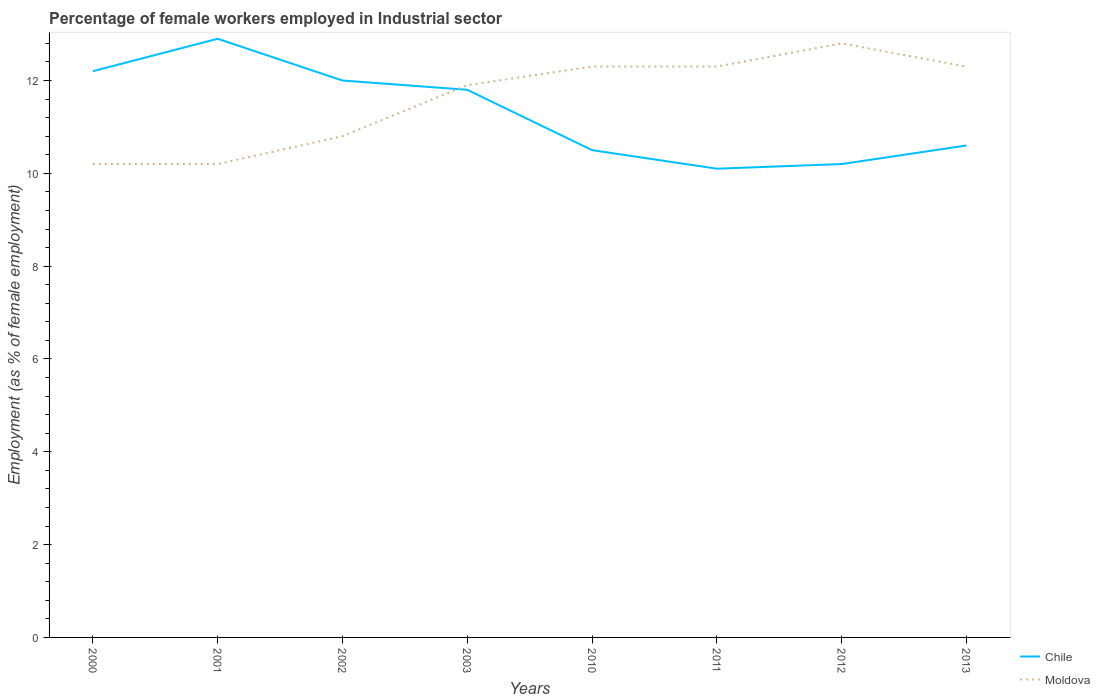How many different coloured lines are there?
Offer a terse response. 2. Is the number of lines equal to the number of legend labels?
Offer a very short reply. Yes. Across all years, what is the maximum percentage of females employed in Industrial sector in Moldova?
Offer a terse response. 10.2. What is the total percentage of females employed in Industrial sector in Chile in the graph?
Keep it short and to the point. 0.2. What is the difference between the highest and the second highest percentage of females employed in Industrial sector in Moldova?
Your response must be concise. 2.6. How many years are there in the graph?
Provide a short and direct response. 8. Are the values on the major ticks of Y-axis written in scientific E-notation?
Provide a succinct answer. No. Where does the legend appear in the graph?
Keep it short and to the point. Bottom right. What is the title of the graph?
Keep it short and to the point. Percentage of female workers employed in Industrial sector. What is the label or title of the Y-axis?
Your answer should be compact. Employment (as % of female employment). What is the Employment (as % of female employment) of Chile in 2000?
Your answer should be very brief. 12.2. What is the Employment (as % of female employment) in Moldova in 2000?
Provide a succinct answer. 10.2. What is the Employment (as % of female employment) of Chile in 2001?
Offer a very short reply. 12.9. What is the Employment (as % of female employment) of Moldova in 2001?
Offer a terse response. 10.2. What is the Employment (as % of female employment) in Moldova in 2002?
Your answer should be compact. 10.8. What is the Employment (as % of female employment) in Chile in 2003?
Ensure brevity in your answer.  11.8. What is the Employment (as % of female employment) of Moldova in 2003?
Keep it short and to the point. 11.9. What is the Employment (as % of female employment) of Moldova in 2010?
Provide a succinct answer. 12.3. What is the Employment (as % of female employment) of Chile in 2011?
Provide a succinct answer. 10.1. What is the Employment (as % of female employment) in Moldova in 2011?
Give a very brief answer. 12.3. What is the Employment (as % of female employment) in Chile in 2012?
Offer a terse response. 10.2. What is the Employment (as % of female employment) of Moldova in 2012?
Your answer should be compact. 12.8. What is the Employment (as % of female employment) of Chile in 2013?
Offer a very short reply. 10.6. What is the Employment (as % of female employment) in Moldova in 2013?
Your answer should be very brief. 12.3. Across all years, what is the maximum Employment (as % of female employment) in Chile?
Your answer should be very brief. 12.9. Across all years, what is the maximum Employment (as % of female employment) of Moldova?
Provide a succinct answer. 12.8. Across all years, what is the minimum Employment (as % of female employment) in Chile?
Your response must be concise. 10.1. Across all years, what is the minimum Employment (as % of female employment) of Moldova?
Provide a short and direct response. 10.2. What is the total Employment (as % of female employment) of Chile in the graph?
Offer a very short reply. 90.3. What is the total Employment (as % of female employment) in Moldova in the graph?
Provide a succinct answer. 92.8. What is the difference between the Employment (as % of female employment) in Chile in 2000 and that in 2001?
Keep it short and to the point. -0.7. What is the difference between the Employment (as % of female employment) of Chile in 2000 and that in 2002?
Provide a short and direct response. 0.2. What is the difference between the Employment (as % of female employment) of Moldova in 2000 and that in 2003?
Your answer should be compact. -1.7. What is the difference between the Employment (as % of female employment) of Chile in 2000 and that in 2010?
Offer a very short reply. 1.7. What is the difference between the Employment (as % of female employment) in Moldova in 2000 and that in 2010?
Give a very brief answer. -2.1. What is the difference between the Employment (as % of female employment) of Chile in 2000 and that in 2011?
Your answer should be very brief. 2.1. What is the difference between the Employment (as % of female employment) of Moldova in 2000 and that in 2011?
Offer a very short reply. -2.1. What is the difference between the Employment (as % of female employment) in Moldova in 2000 and that in 2012?
Offer a very short reply. -2.6. What is the difference between the Employment (as % of female employment) in Chile in 2001 and that in 2002?
Ensure brevity in your answer.  0.9. What is the difference between the Employment (as % of female employment) of Chile in 2001 and that in 2010?
Your answer should be compact. 2.4. What is the difference between the Employment (as % of female employment) in Chile in 2001 and that in 2011?
Make the answer very short. 2.8. What is the difference between the Employment (as % of female employment) in Moldova in 2001 and that in 2011?
Keep it short and to the point. -2.1. What is the difference between the Employment (as % of female employment) of Moldova in 2001 and that in 2012?
Provide a short and direct response. -2.6. What is the difference between the Employment (as % of female employment) of Chile in 2001 and that in 2013?
Ensure brevity in your answer.  2.3. What is the difference between the Employment (as % of female employment) of Moldova in 2001 and that in 2013?
Your answer should be very brief. -2.1. What is the difference between the Employment (as % of female employment) of Chile in 2002 and that in 2010?
Give a very brief answer. 1.5. What is the difference between the Employment (as % of female employment) of Chile in 2002 and that in 2012?
Make the answer very short. 1.8. What is the difference between the Employment (as % of female employment) of Chile in 2003 and that in 2011?
Your answer should be compact. 1.7. What is the difference between the Employment (as % of female employment) of Chile in 2003 and that in 2012?
Provide a short and direct response. 1.6. What is the difference between the Employment (as % of female employment) in Moldova in 2003 and that in 2012?
Provide a succinct answer. -0.9. What is the difference between the Employment (as % of female employment) in Chile in 2003 and that in 2013?
Provide a short and direct response. 1.2. What is the difference between the Employment (as % of female employment) of Moldova in 2003 and that in 2013?
Offer a very short reply. -0.4. What is the difference between the Employment (as % of female employment) of Moldova in 2010 and that in 2011?
Provide a succinct answer. 0. What is the difference between the Employment (as % of female employment) in Chile in 2010 and that in 2012?
Give a very brief answer. 0.3. What is the difference between the Employment (as % of female employment) in Moldova in 2010 and that in 2012?
Offer a terse response. -0.5. What is the difference between the Employment (as % of female employment) in Moldova in 2010 and that in 2013?
Your answer should be compact. 0. What is the difference between the Employment (as % of female employment) of Chile in 2011 and that in 2012?
Provide a succinct answer. -0.1. What is the difference between the Employment (as % of female employment) in Moldova in 2011 and that in 2012?
Your answer should be very brief. -0.5. What is the difference between the Employment (as % of female employment) of Chile in 2011 and that in 2013?
Offer a very short reply. -0.5. What is the difference between the Employment (as % of female employment) in Chile in 2012 and that in 2013?
Your response must be concise. -0.4. What is the difference between the Employment (as % of female employment) of Moldova in 2012 and that in 2013?
Provide a succinct answer. 0.5. What is the difference between the Employment (as % of female employment) of Chile in 2000 and the Employment (as % of female employment) of Moldova in 2001?
Your answer should be compact. 2. What is the difference between the Employment (as % of female employment) of Chile in 2000 and the Employment (as % of female employment) of Moldova in 2003?
Provide a succinct answer. 0.3. What is the difference between the Employment (as % of female employment) of Chile in 2000 and the Employment (as % of female employment) of Moldova in 2010?
Offer a terse response. -0.1. What is the difference between the Employment (as % of female employment) of Chile in 2000 and the Employment (as % of female employment) of Moldova in 2012?
Provide a short and direct response. -0.6. What is the difference between the Employment (as % of female employment) in Chile in 2000 and the Employment (as % of female employment) in Moldova in 2013?
Offer a very short reply. -0.1. What is the difference between the Employment (as % of female employment) of Chile in 2001 and the Employment (as % of female employment) of Moldova in 2003?
Your answer should be very brief. 1. What is the difference between the Employment (as % of female employment) of Chile in 2001 and the Employment (as % of female employment) of Moldova in 2012?
Your answer should be very brief. 0.1. What is the difference between the Employment (as % of female employment) of Chile in 2001 and the Employment (as % of female employment) of Moldova in 2013?
Offer a terse response. 0.6. What is the difference between the Employment (as % of female employment) in Chile in 2002 and the Employment (as % of female employment) in Moldova in 2010?
Provide a short and direct response. -0.3. What is the difference between the Employment (as % of female employment) in Chile in 2002 and the Employment (as % of female employment) in Moldova in 2011?
Offer a very short reply. -0.3. What is the difference between the Employment (as % of female employment) in Chile in 2002 and the Employment (as % of female employment) in Moldova in 2013?
Your response must be concise. -0.3. What is the difference between the Employment (as % of female employment) in Chile in 2003 and the Employment (as % of female employment) in Moldova in 2010?
Offer a very short reply. -0.5. What is the difference between the Employment (as % of female employment) in Chile in 2003 and the Employment (as % of female employment) in Moldova in 2012?
Provide a succinct answer. -1. What is the difference between the Employment (as % of female employment) in Chile in 2003 and the Employment (as % of female employment) in Moldova in 2013?
Your answer should be very brief. -0.5. What is the difference between the Employment (as % of female employment) of Chile in 2010 and the Employment (as % of female employment) of Moldova in 2011?
Ensure brevity in your answer.  -1.8. What is the difference between the Employment (as % of female employment) in Chile in 2010 and the Employment (as % of female employment) in Moldova in 2013?
Your answer should be very brief. -1.8. What is the difference between the Employment (as % of female employment) of Chile in 2011 and the Employment (as % of female employment) of Moldova in 2012?
Offer a very short reply. -2.7. What is the average Employment (as % of female employment) of Chile per year?
Provide a short and direct response. 11.29. In the year 2000, what is the difference between the Employment (as % of female employment) of Chile and Employment (as % of female employment) of Moldova?
Offer a terse response. 2. In the year 2002, what is the difference between the Employment (as % of female employment) of Chile and Employment (as % of female employment) of Moldova?
Your response must be concise. 1.2. In the year 2010, what is the difference between the Employment (as % of female employment) in Chile and Employment (as % of female employment) in Moldova?
Offer a very short reply. -1.8. In the year 2011, what is the difference between the Employment (as % of female employment) in Chile and Employment (as % of female employment) in Moldova?
Your response must be concise. -2.2. In the year 2013, what is the difference between the Employment (as % of female employment) of Chile and Employment (as % of female employment) of Moldova?
Keep it short and to the point. -1.7. What is the ratio of the Employment (as % of female employment) of Chile in 2000 to that in 2001?
Your answer should be compact. 0.95. What is the ratio of the Employment (as % of female employment) of Chile in 2000 to that in 2002?
Keep it short and to the point. 1.02. What is the ratio of the Employment (as % of female employment) of Chile in 2000 to that in 2003?
Provide a short and direct response. 1.03. What is the ratio of the Employment (as % of female employment) of Chile in 2000 to that in 2010?
Provide a succinct answer. 1.16. What is the ratio of the Employment (as % of female employment) in Moldova in 2000 to that in 2010?
Provide a short and direct response. 0.83. What is the ratio of the Employment (as % of female employment) in Chile in 2000 to that in 2011?
Provide a short and direct response. 1.21. What is the ratio of the Employment (as % of female employment) in Moldova in 2000 to that in 2011?
Keep it short and to the point. 0.83. What is the ratio of the Employment (as % of female employment) in Chile in 2000 to that in 2012?
Your response must be concise. 1.2. What is the ratio of the Employment (as % of female employment) in Moldova in 2000 to that in 2012?
Give a very brief answer. 0.8. What is the ratio of the Employment (as % of female employment) of Chile in 2000 to that in 2013?
Your answer should be compact. 1.15. What is the ratio of the Employment (as % of female employment) in Moldova in 2000 to that in 2013?
Your response must be concise. 0.83. What is the ratio of the Employment (as % of female employment) of Chile in 2001 to that in 2002?
Offer a very short reply. 1.07. What is the ratio of the Employment (as % of female employment) of Moldova in 2001 to that in 2002?
Keep it short and to the point. 0.94. What is the ratio of the Employment (as % of female employment) of Chile in 2001 to that in 2003?
Keep it short and to the point. 1.09. What is the ratio of the Employment (as % of female employment) of Moldova in 2001 to that in 2003?
Provide a succinct answer. 0.86. What is the ratio of the Employment (as % of female employment) in Chile in 2001 to that in 2010?
Your answer should be compact. 1.23. What is the ratio of the Employment (as % of female employment) of Moldova in 2001 to that in 2010?
Provide a short and direct response. 0.83. What is the ratio of the Employment (as % of female employment) of Chile in 2001 to that in 2011?
Provide a short and direct response. 1.28. What is the ratio of the Employment (as % of female employment) of Moldova in 2001 to that in 2011?
Provide a succinct answer. 0.83. What is the ratio of the Employment (as % of female employment) of Chile in 2001 to that in 2012?
Offer a very short reply. 1.26. What is the ratio of the Employment (as % of female employment) of Moldova in 2001 to that in 2012?
Provide a short and direct response. 0.8. What is the ratio of the Employment (as % of female employment) of Chile in 2001 to that in 2013?
Give a very brief answer. 1.22. What is the ratio of the Employment (as % of female employment) of Moldova in 2001 to that in 2013?
Offer a terse response. 0.83. What is the ratio of the Employment (as % of female employment) of Chile in 2002 to that in 2003?
Keep it short and to the point. 1.02. What is the ratio of the Employment (as % of female employment) in Moldova in 2002 to that in 2003?
Keep it short and to the point. 0.91. What is the ratio of the Employment (as % of female employment) of Moldova in 2002 to that in 2010?
Your response must be concise. 0.88. What is the ratio of the Employment (as % of female employment) in Chile in 2002 to that in 2011?
Provide a succinct answer. 1.19. What is the ratio of the Employment (as % of female employment) of Moldova in 2002 to that in 2011?
Your response must be concise. 0.88. What is the ratio of the Employment (as % of female employment) in Chile in 2002 to that in 2012?
Keep it short and to the point. 1.18. What is the ratio of the Employment (as % of female employment) of Moldova in 2002 to that in 2012?
Your answer should be compact. 0.84. What is the ratio of the Employment (as % of female employment) of Chile in 2002 to that in 2013?
Offer a terse response. 1.13. What is the ratio of the Employment (as % of female employment) of Moldova in 2002 to that in 2013?
Your answer should be very brief. 0.88. What is the ratio of the Employment (as % of female employment) in Chile in 2003 to that in 2010?
Provide a short and direct response. 1.12. What is the ratio of the Employment (as % of female employment) in Moldova in 2003 to that in 2010?
Your answer should be very brief. 0.97. What is the ratio of the Employment (as % of female employment) in Chile in 2003 to that in 2011?
Give a very brief answer. 1.17. What is the ratio of the Employment (as % of female employment) of Moldova in 2003 to that in 2011?
Provide a short and direct response. 0.97. What is the ratio of the Employment (as % of female employment) in Chile in 2003 to that in 2012?
Keep it short and to the point. 1.16. What is the ratio of the Employment (as % of female employment) in Moldova in 2003 to that in 2012?
Give a very brief answer. 0.93. What is the ratio of the Employment (as % of female employment) of Chile in 2003 to that in 2013?
Offer a very short reply. 1.11. What is the ratio of the Employment (as % of female employment) of Moldova in 2003 to that in 2013?
Make the answer very short. 0.97. What is the ratio of the Employment (as % of female employment) in Chile in 2010 to that in 2011?
Offer a terse response. 1.04. What is the ratio of the Employment (as % of female employment) of Moldova in 2010 to that in 2011?
Provide a short and direct response. 1. What is the ratio of the Employment (as % of female employment) of Chile in 2010 to that in 2012?
Your answer should be compact. 1.03. What is the ratio of the Employment (as % of female employment) in Moldova in 2010 to that in 2012?
Offer a terse response. 0.96. What is the ratio of the Employment (as % of female employment) in Chile in 2010 to that in 2013?
Your answer should be compact. 0.99. What is the ratio of the Employment (as % of female employment) of Chile in 2011 to that in 2012?
Provide a short and direct response. 0.99. What is the ratio of the Employment (as % of female employment) of Moldova in 2011 to that in 2012?
Your answer should be compact. 0.96. What is the ratio of the Employment (as % of female employment) of Chile in 2011 to that in 2013?
Provide a succinct answer. 0.95. What is the ratio of the Employment (as % of female employment) in Chile in 2012 to that in 2013?
Give a very brief answer. 0.96. What is the ratio of the Employment (as % of female employment) of Moldova in 2012 to that in 2013?
Offer a terse response. 1.04. What is the difference between the highest and the second highest Employment (as % of female employment) in Chile?
Keep it short and to the point. 0.7. What is the difference between the highest and the second highest Employment (as % of female employment) of Moldova?
Offer a terse response. 0.5. What is the difference between the highest and the lowest Employment (as % of female employment) in Chile?
Give a very brief answer. 2.8. What is the difference between the highest and the lowest Employment (as % of female employment) of Moldova?
Offer a terse response. 2.6. 